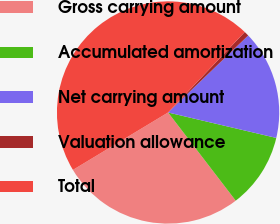Convert chart to OTSL. <chart><loc_0><loc_0><loc_500><loc_500><pie_chart><fcel>Gross carrying amount<fcel>Accumulated amortization<fcel>Net carrying amount<fcel>Valuation allowance<fcel>Total<nl><fcel>26.77%<fcel>10.91%<fcel>15.86%<fcel>0.7%<fcel>45.75%<nl></chart> 